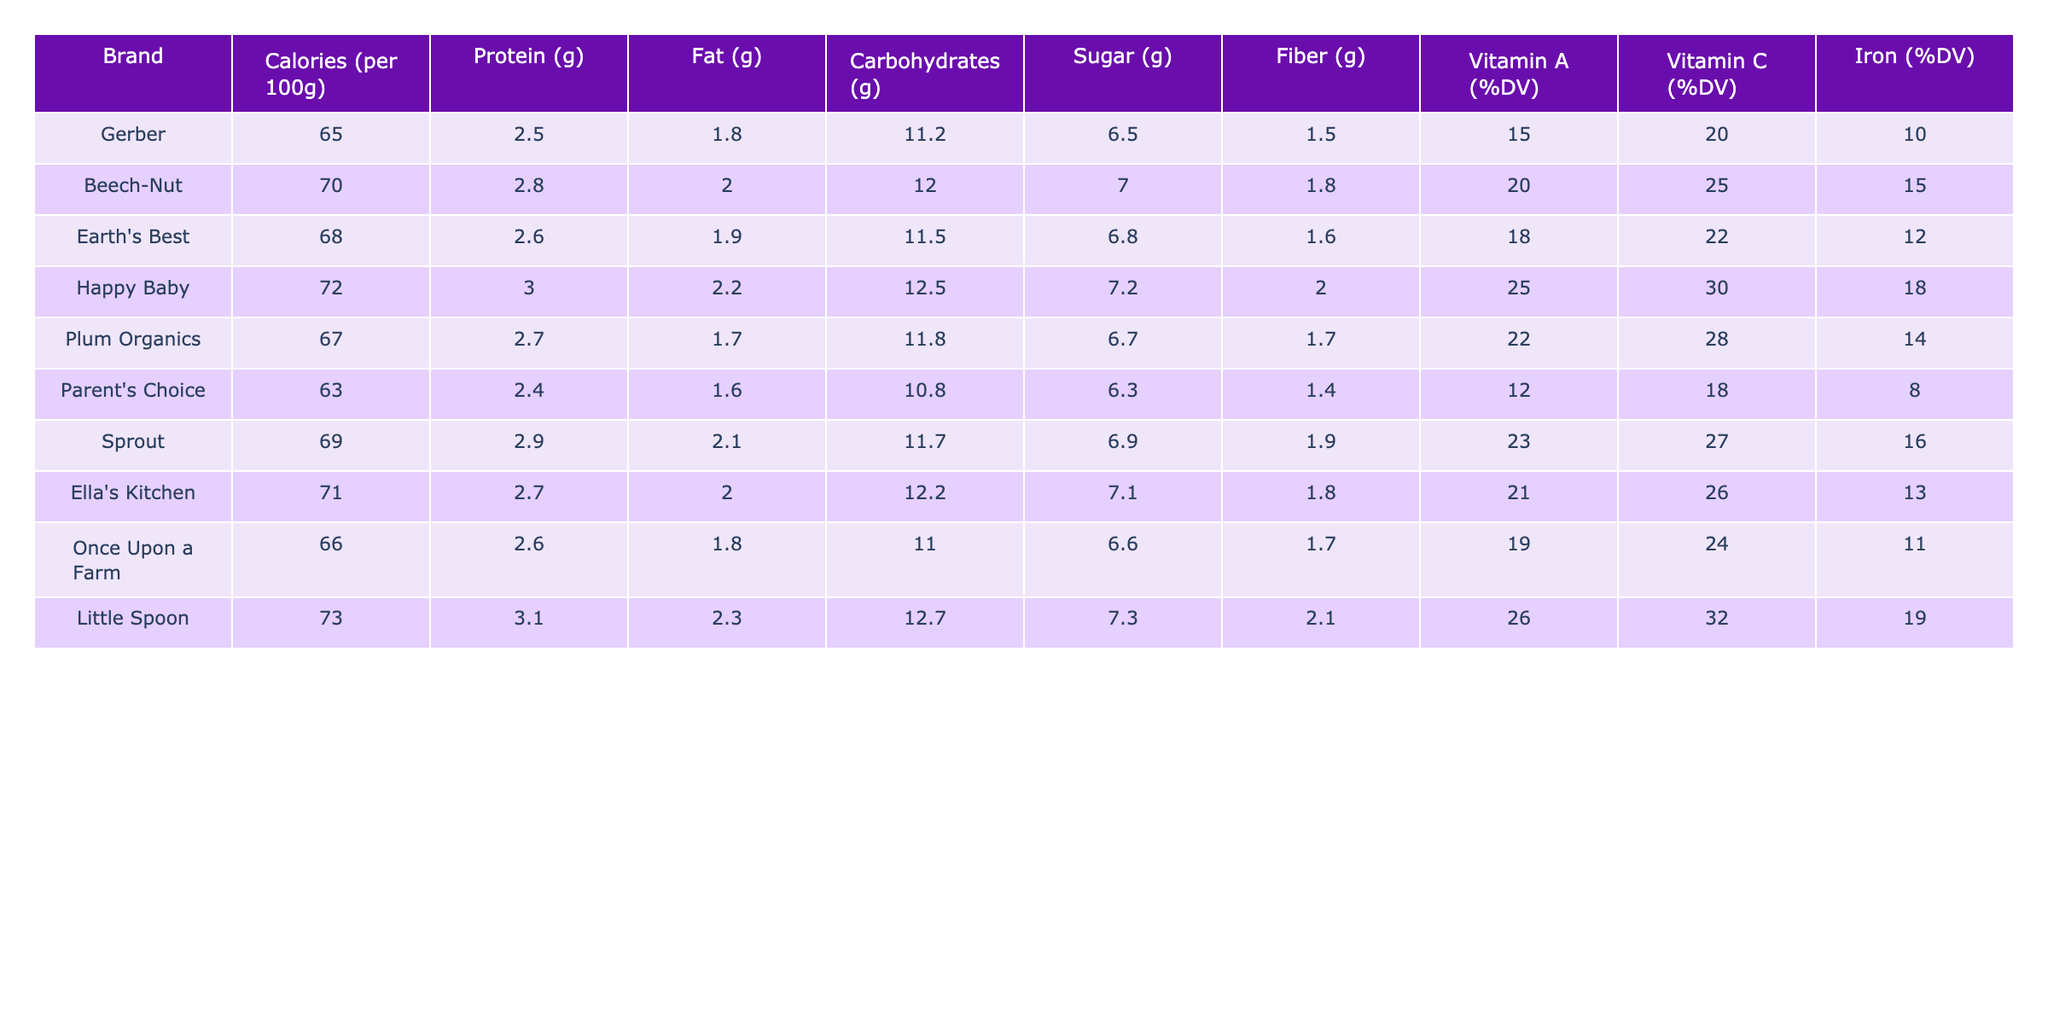What brand has the highest protein content? The protein content for each brand is listed in the table. I can see that Happy Baby has the highest protein content with 3.0 grams per 100 grams of baby food.
Answer: Happy Baby Which brand contains the least amount of calories? I can identify the calorie content for each brand in the table. Parent's Choice has the lowest calorie count at 63 calories per 100 grams.
Answer: Parent's Choice What is the average sugar content across all brands? I can add up the sugar content for all brands: (6.5 + 7.0 + 6.8 + 7.2 + 6.7 + 6.3 + 6.9 + 7.1 + 6.6 + 7.3) = 68.6 grams. Then, I divide by 10 (the number of brands), which gives me an average sugar content of 6.86 grams.
Answer: 6.86 grams Does any brand provide a good source of Vitamin A with more than 25% of the daily value? By looking at the Vitamin A (%DV) values, I can see that Happy Baby and Little Spoon both provide more than 25% of the daily value (25% and 26%, respectively). Therefore, the statement is true.
Answer: Yes Which brand provides the highest fiber content? In the table, I can compare the fiber content across all brands. Little Spoon has the highest fiber content with 2.1 grams per 100 grams.
Answer: Little Spoon Is Beech-Nut richer in iron than Gerber? I check the iron (%DV) values for both brands: Beech-Nut has 15% and Gerber has 10%. Since 15% is greater than 10%, Beech-Nut is indeed richer in iron than Gerber.
Answer: Yes What is the difference in fat content between the brand with the highest and the brand with the lowest fat content? The highest fat content is in Happy Baby with 2.2 grams, and the lowest is in Parent's Choice with 1.6 grams. To find the difference, I subtract 1.6 from 2.2, which equals 0.6 grams.
Answer: 0.6 grams Which brand has fewer carbohydrates, Gerber or Earth's Best? By comparing the carbohydrate values in the table, Gerber has 11.2 grams, while Earth's Best has 11.5 grams. Therefore, Gerber has fewer carbohydrates than Earth's Best.
Answer: Yes What brand is the best source of Vitamin C? Looking at the Vitamin C (%DV) data in the table, I can see that Little Spoon provides 32% of the daily value, which is the highest among all brands.
Answer: Little Spoon Is the fiber content of Sprout more than the average fiber content across all brands? First, I sum the fiber content: (1.5 + 1.8 + 1.6 + 2.0 + 1.7 + 1.4 + 1.9 + 1.8 + 1.7 + 2.1) = 18.6 grams. Then I divide this by 10, which gives me an average of 1.86 grams. Since Sprout has 1.9 grams, it is more than the average.
Answer: Yes 